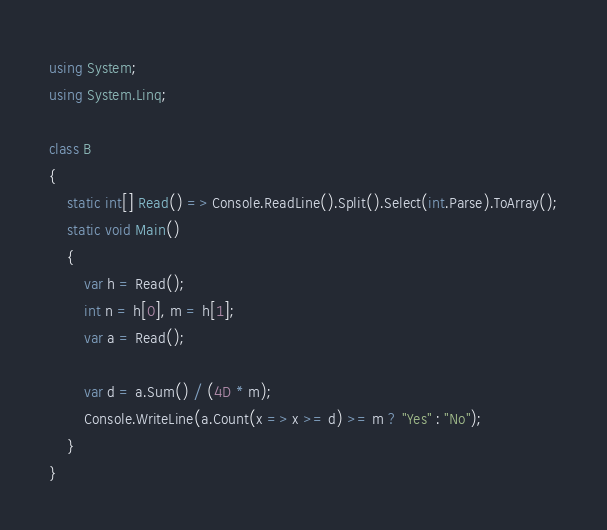Convert code to text. <code><loc_0><loc_0><loc_500><loc_500><_C#_>using System;
using System.Linq;

class B
{
	static int[] Read() => Console.ReadLine().Split().Select(int.Parse).ToArray();
	static void Main()
	{
		var h = Read();
		int n = h[0], m = h[1];
		var a = Read();

		var d = a.Sum() / (4D * m);
		Console.WriteLine(a.Count(x => x >= d) >= m ? "Yes" : "No");
	}
}
</code> 